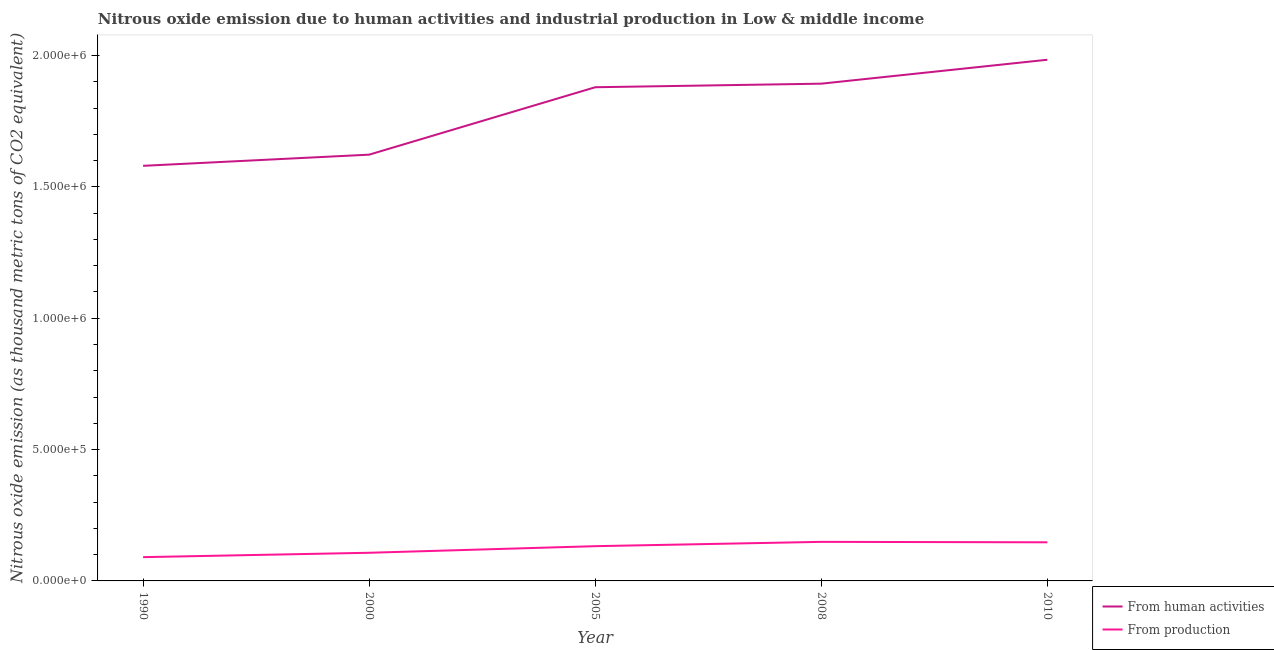How many different coloured lines are there?
Keep it short and to the point. 2. What is the amount of emissions from human activities in 2010?
Ensure brevity in your answer.  1.98e+06. Across all years, what is the maximum amount of emissions from human activities?
Ensure brevity in your answer.  1.98e+06. Across all years, what is the minimum amount of emissions from human activities?
Provide a succinct answer. 1.58e+06. What is the total amount of emissions generated from industries in the graph?
Offer a very short reply. 6.26e+05. What is the difference between the amount of emissions generated from industries in 2008 and that in 2010?
Provide a short and direct response. 1688.4. What is the difference between the amount of emissions from human activities in 2005 and the amount of emissions generated from industries in 2010?
Offer a very short reply. 1.73e+06. What is the average amount of emissions generated from industries per year?
Make the answer very short. 1.25e+05. In the year 2000, what is the difference between the amount of emissions generated from industries and amount of emissions from human activities?
Make the answer very short. -1.52e+06. What is the ratio of the amount of emissions from human activities in 1990 to that in 2000?
Offer a terse response. 0.97. What is the difference between the highest and the second highest amount of emissions from human activities?
Offer a very short reply. 9.11e+04. What is the difference between the highest and the lowest amount of emissions generated from industries?
Provide a short and direct response. 5.82e+04. In how many years, is the amount of emissions generated from industries greater than the average amount of emissions generated from industries taken over all years?
Your answer should be compact. 3. Are the values on the major ticks of Y-axis written in scientific E-notation?
Your answer should be very brief. Yes. How many legend labels are there?
Make the answer very short. 2. How are the legend labels stacked?
Your answer should be compact. Vertical. What is the title of the graph?
Provide a short and direct response. Nitrous oxide emission due to human activities and industrial production in Low & middle income. Does "Urban Population" appear as one of the legend labels in the graph?
Keep it short and to the point. No. What is the label or title of the Y-axis?
Offer a very short reply. Nitrous oxide emission (as thousand metric tons of CO2 equivalent). What is the Nitrous oxide emission (as thousand metric tons of CO2 equivalent) of From human activities in 1990?
Your answer should be compact. 1.58e+06. What is the Nitrous oxide emission (as thousand metric tons of CO2 equivalent) in From production in 1990?
Keep it short and to the point. 9.05e+04. What is the Nitrous oxide emission (as thousand metric tons of CO2 equivalent) in From human activities in 2000?
Ensure brevity in your answer.  1.62e+06. What is the Nitrous oxide emission (as thousand metric tons of CO2 equivalent) of From production in 2000?
Offer a very short reply. 1.07e+05. What is the Nitrous oxide emission (as thousand metric tons of CO2 equivalent) of From human activities in 2005?
Your answer should be very brief. 1.88e+06. What is the Nitrous oxide emission (as thousand metric tons of CO2 equivalent) in From production in 2005?
Provide a short and direct response. 1.32e+05. What is the Nitrous oxide emission (as thousand metric tons of CO2 equivalent) of From human activities in 2008?
Offer a terse response. 1.89e+06. What is the Nitrous oxide emission (as thousand metric tons of CO2 equivalent) of From production in 2008?
Provide a succinct answer. 1.49e+05. What is the Nitrous oxide emission (as thousand metric tons of CO2 equivalent) in From human activities in 2010?
Your answer should be compact. 1.98e+06. What is the Nitrous oxide emission (as thousand metric tons of CO2 equivalent) of From production in 2010?
Keep it short and to the point. 1.47e+05. Across all years, what is the maximum Nitrous oxide emission (as thousand metric tons of CO2 equivalent) in From human activities?
Provide a short and direct response. 1.98e+06. Across all years, what is the maximum Nitrous oxide emission (as thousand metric tons of CO2 equivalent) in From production?
Provide a succinct answer. 1.49e+05. Across all years, what is the minimum Nitrous oxide emission (as thousand metric tons of CO2 equivalent) of From human activities?
Ensure brevity in your answer.  1.58e+06. Across all years, what is the minimum Nitrous oxide emission (as thousand metric tons of CO2 equivalent) in From production?
Keep it short and to the point. 9.05e+04. What is the total Nitrous oxide emission (as thousand metric tons of CO2 equivalent) of From human activities in the graph?
Provide a succinct answer. 8.96e+06. What is the total Nitrous oxide emission (as thousand metric tons of CO2 equivalent) of From production in the graph?
Offer a terse response. 6.26e+05. What is the difference between the Nitrous oxide emission (as thousand metric tons of CO2 equivalent) of From human activities in 1990 and that in 2000?
Give a very brief answer. -4.25e+04. What is the difference between the Nitrous oxide emission (as thousand metric tons of CO2 equivalent) in From production in 1990 and that in 2000?
Provide a succinct answer. -1.66e+04. What is the difference between the Nitrous oxide emission (as thousand metric tons of CO2 equivalent) in From human activities in 1990 and that in 2005?
Offer a very short reply. -2.99e+05. What is the difference between the Nitrous oxide emission (as thousand metric tons of CO2 equivalent) of From production in 1990 and that in 2005?
Give a very brief answer. -4.18e+04. What is the difference between the Nitrous oxide emission (as thousand metric tons of CO2 equivalent) in From human activities in 1990 and that in 2008?
Your answer should be compact. -3.13e+05. What is the difference between the Nitrous oxide emission (as thousand metric tons of CO2 equivalent) of From production in 1990 and that in 2008?
Provide a short and direct response. -5.82e+04. What is the difference between the Nitrous oxide emission (as thousand metric tons of CO2 equivalent) of From human activities in 1990 and that in 2010?
Your answer should be compact. -4.04e+05. What is the difference between the Nitrous oxide emission (as thousand metric tons of CO2 equivalent) in From production in 1990 and that in 2010?
Ensure brevity in your answer.  -5.65e+04. What is the difference between the Nitrous oxide emission (as thousand metric tons of CO2 equivalent) in From human activities in 2000 and that in 2005?
Make the answer very short. -2.57e+05. What is the difference between the Nitrous oxide emission (as thousand metric tons of CO2 equivalent) of From production in 2000 and that in 2005?
Your answer should be compact. -2.51e+04. What is the difference between the Nitrous oxide emission (as thousand metric tons of CO2 equivalent) of From human activities in 2000 and that in 2008?
Offer a very short reply. -2.70e+05. What is the difference between the Nitrous oxide emission (as thousand metric tons of CO2 equivalent) in From production in 2000 and that in 2008?
Keep it short and to the point. -4.16e+04. What is the difference between the Nitrous oxide emission (as thousand metric tons of CO2 equivalent) in From human activities in 2000 and that in 2010?
Your answer should be compact. -3.61e+05. What is the difference between the Nitrous oxide emission (as thousand metric tons of CO2 equivalent) of From production in 2000 and that in 2010?
Your response must be concise. -3.99e+04. What is the difference between the Nitrous oxide emission (as thousand metric tons of CO2 equivalent) in From human activities in 2005 and that in 2008?
Your response must be concise. -1.36e+04. What is the difference between the Nitrous oxide emission (as thousand metric tons of CO2 equivalent) in From production in 2005 and that in 2008?
Give a very brief answer. -1.64e+04. What is the difference between the Nitrous oxide emission (as thousand metric tons of CO2 equivalent) in From human activities in 2005 and that in 2010?
Your answer should be very brief. -1.05e+05. What is the difference between the Nitrous oxide emission (as thousand metric tons of CO2 equivalent) of From production in 2005 and that in 2010?
Provide a short and direct response. -1.47e+04. What is the difference between the Nitrous oxide emission (as thousand metric tons of CO2 equivalent) of From human activities in 2008 and that in 2010?
Your answer should be very brief. -9.11e+04. What is the difference between the Nitrous oxide emission (as thousand metric tons of CO2 equivalent) in From production in 2008 and that in 2010?
Your response must be concise. 1688.4. What is the difference between the Nitrous oxide emission (as thousand metric tons of CO2 equivalent) in From human activities in 1990 and the Nitrous oxide emission (as thousand metric tons of CO2 equivalent) in From production in 2000?
Keep it short and to the point. 1.47e+06. What is the difference between the Nitrous oxide emission (as thousand metric tons of CO2 equivalent) of From human activities in 1990 and the Nitrous oxide emission (as thousand metric tons of CO2 equivalent) of From production in 2005?
Give a very brief answer. 1.45e+06. What is the difference between the Nitrous oxide emission (as thousand metric tons of CO2 equivalent) in From human activities in 1990 and the Nitrous oxide emission (as thousand metric tons of CO2 equivalent) in From production in 2008?
Make the answer very short. 1.43e+06. What is the difference between the Nitrous oxide emission (as thousand metric tons of CO2 equivalent) in From human activities in 1990 and the Nitrous oxide emission (as thousand metric tons of CO2 equivalent) in From production in 2010?
Your answer should be compact. 1.43e+06. What is the difference between the Nitrous oxide emission (as thousand metric tons of CO2 equivalent) in From human activities in 2000 and the Nitrous oxide emission (as thousand metric tons of CO2 equivalent) in From production in 2005?
Your response must be concise. 1.49e+06. What is the difference between the Nitrous oxide emission (as thousand metric tons of CO2 equivalent) of From human activities in 2000 and the Nitrous oxide emission (as thousand metric tons of CO2 equivalent) of From production in 2008?
Offer a very short reply. 1.47e+06. What is the difference between the Nitrous oxide emission (as thousand metric tons of CO2 equivalent) of From human activities in 2000 and the Nitrous oxide emission (as thousand metric tons of CO2 equivalent) of From production in 2010?
Provide a succinct answer. 1.48e+06. What is the difference between the Nitrous oxide emission (as thousand metric tons of CO2 equivalent) in From human activities in 2005 and the Nitrous oxide emission (as thousand metric tons of CO2 equivalent) in From production in 2008?
Offer a very short reply. 1.73e+06. What is the difference between the Nitrous oxide emission (as thousand metric tons of CO2 equivalent) in From human activities in 2005 and the Nitrous oxide emission (as thousand metric tons of CO2 equivalent) in From production in 2010?
Ensure brevity in your answer.  1.73e+06. What is the difference between the Nitrous oxide emission (as thousand metric tons of CO2 equivalent) of From human activities in 2008 and the Nitrous oxide emission (as thousand metric tons of CO2 equivalent) of From production in 2010?
Your answer should be very brief. 1.75e+06. What is the average Nitrous oxide emission (as thousand metric tons of CO2 equivalent) of From human activities per year?
Your answer should be compact. 1.79e+06. What is the average Nitrous oxide emission (as thousand metric tons of CO2 equivalent) in From production per year?
Ensure brevity in your answer.  1.25e+05. In the year 1990, what is the difference between the Nitrous oxide emission (as thousand metric tons of CO2 equivalent) of From human activities and Nitrous oxide emission (as thousand metric tons of CO2 equivalent) of From production?
Offer a terse response. 1.49e+06. In the year 2000, what is the difference between the Nitrous oxide emission (as thousand metric tons of CO2 equivalent) of From human activities and Nitrous oxide emission (as thousand metric tons of CO2 equivalent) of From production?
Provide a short and direct response. 1.52e+06. In the year 2005, what is the difference between the Nitrous oxide emission (as thousand metric tons of CO2 equivalent) in From human activities and Nitrous oxide emission (as thousand metric tons of CO2 equivalent) in From production?
Keep it short and to the point. 1.75e+06. In the year 2008, what is the difference between the Nitrous oxide emission (as thousand metric tons of CO2 equivalent) of From human activities and Nitrous oxide emission (as thousand metric tons of CO2 equivalent) of From production?
Your response must be concise. 1.74e+06. In the year 2010, what is the difference between the Nitrous oxide emission (as thousand metric tons of CO2 equivalent) of From human activities and Nitrous oxide emission (as thousand metric tons of CO2 equivalent) of From production?
Give a very brief answer. 1.84e+06. What is the ratio of the Nitrous oxide emission (as thousand metric tons of CO2 equivalent) of From human activities in 1990 to that in 2000?
Make the answer very short. 0.97. What is the ratio of the Nitrous oxide emission (as thousand metric tons of CO2 equivalent) in From production in 1990 to that in 2000?
Offer a very short reply. 0.84. What is the ratio of the Nitrous oxide emission (as thousand metric tons of CO2 equivalent) of From human activities in 1990 to that in 2005?
Keep it short and to the point. 0.84. What is the ratio of the Nitrous oxide emission (as thousand metric tons of CO2 equivalent) in From production in 1990 to that in 2005?
Ensure brevity in your answer.  0.68. What is the ratio of the Nitrous oxide emission (as thousand metric tons of CO2 equivalent) in From human activities in 1990 to that in 2008?
Keep it short and to the point. 0.83. What is the ratio of the Nitrous oxide emission (as thousand metric tons of CO2 equivalent) in From production in 1990 to that in 2008?
Provide a short and direct response. 0.61. What is the ratio of the Nitrous oxide emission (as thousand metric tons of CO2 equivalent) in From human activities in 1990 to that in 2010?
Your response must be concise. 0.8. What is the ratio of the Nitrous oxide emission (as thousand metric tons of CO2 equivalent) of From production in 1990 to that in 2010?
Offer a terse response. 0.62. What is the ratio of the Nitrous oxide emission (as thousand metric tons of CO2 equivalent) of From human activities in 2000 to that in 2005?
Make the answer very short. 0.86. What is the ratio of the Nitrous oxide emission (as thousand metric tons of CO2 equivalent) of From production in 2000 to that in 2005?
Provide a succinct answer. 0.81. What is the ratio of the Nitrous oxide emission (as thousand metric tons of CO2 equivalent) of From human activities in 2000 to that in 2008?
Your response must be concise. 0.86. What is the ratio of the Nitrous oxide emission (as thousand metric tons of CO2 equivalent) of From production in 2000 to that in 2008?
Offer a very short reply. 0.72. What is the ratio of the Nitrous oxide emission (as thousand metric tons of CO2 equivalent) of From human activities in 2000 to that in 2010?
Make the answer very short. 0.82. What is the ratio of the Nitrous oxide emission (as thousand metric tons of CO2 equivalent) in From production in 2000 to that in 2010?
Make the answer very short. 0.73. What is the ratio of the Nitrous oxide emission (as thousand metric tons of CO2 equivalent) of From human activities in 2005 to that in 2008?
Provide a succinct answer. 0.99. What is the ratio of the Nitrous oxide emission (as thousand metric tons of CO2 equivalent) in From production in 2005 to that in 2008?
Keep it short and to the point. 0.89. What is the ratio of the Nitrous oxide emission (as thousand metric tons of CO2 equivalent) of From human activities in 2005 to that in 2010?
Offer a very short reply. 0.95. What is the ratio of the Nitrous oxide emission (as thousand metric tons of CO2 equivalent) in From production in 2005 to that in 2010?
Ensure brevity in your answer.  0.9. What is the ratio of the Nitrous oxide emission (as thousand metric tons of CO2 equivalent) of From human activities in 2008 to that in 2010?
Provide a succinct answer. 0.95. What is the ratio of the Nitrous oxide emission (as thousand metric tons of CO2 equivalent) of From production in 2008 to that in 2010?
Your response must be concise. 1.01. What is the difference between the highest and the second highest Nitrous oxide emission (as thousand metric tons of CO2 equivalent) in From human activities?
Offer a very short reply. 9.11e+04. What is the difference between the highest and the second highest Nitrous oxide emission (as thousand metric tons of CO2 equivalent) in From production?
Offer a very short reply. 1688.4. What is the difference between the highest and the lowest Nitrous oxide emission (as thousand metric tons of CO2 equivalent) in From human activities?
Make the answer very short. 4.04e+05. What is the difference between the highest and the lowest Nitrous oxide emission (as thousand metric tons of CO2 equivalent) of From production?
Your answer should be very brief. 5.82e+04. 